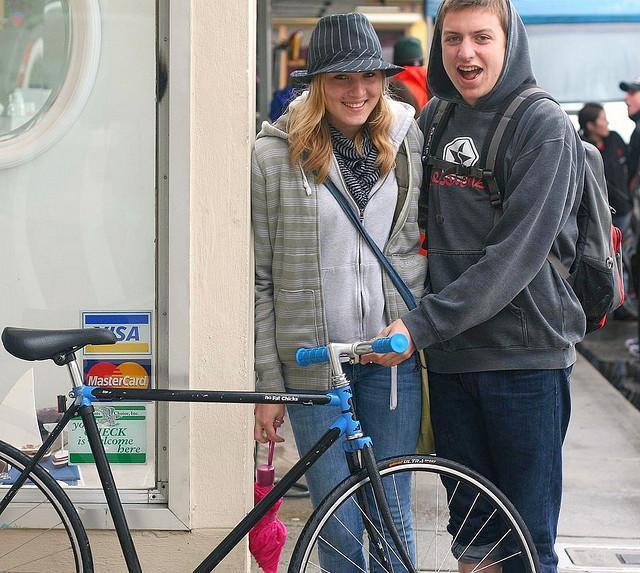How many bikes are in the photo?
Give a very brief answer. 1. How many people are visible?
Give a very brief answer. 4. How many big elephants are there?
Give a very brief answer. 0. 